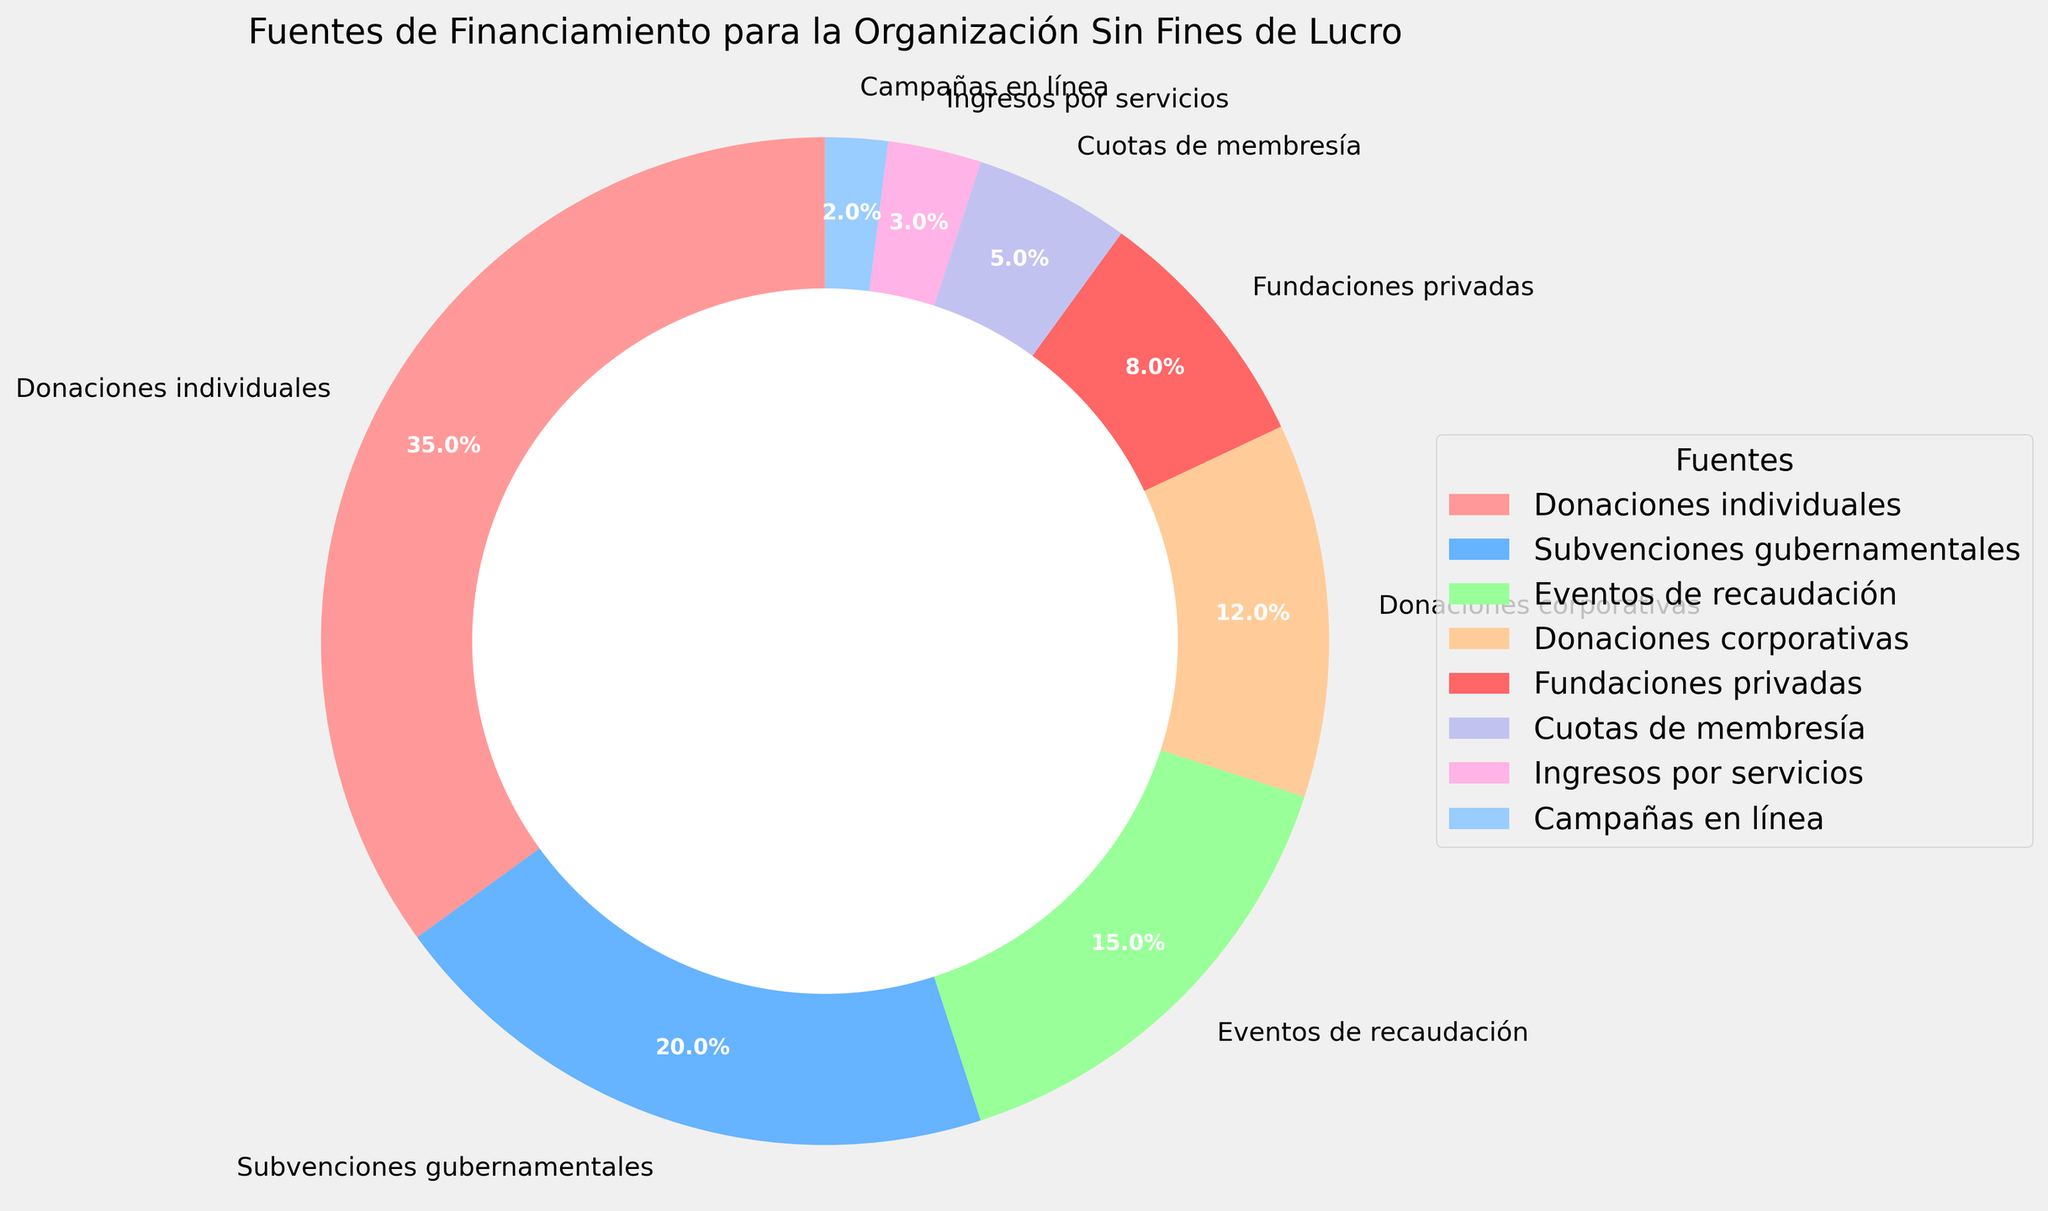Which source of funding has the highest percentage? The pie chart shows that "Donaciones individuales" (Individual Donations) has the largest section which represents 35% of the total funding. Thus, it has the highest percentage compared to other sources.
Answer: Donaciones individuales What is the combined percentage of "Subvenciones gubernamentales" and "Fundaciones privadas"? The percentages for "Subvenciones gubernamentales" (Government Grants) and "Fundaciones privadas" (Private Foundations) provided in the pie chart are 20% and 8%, respectively. Adding them together gives 20% + 8% = 28%.
Answer: 28% How much greater is the percentage of "Donaciones individuales" compared to "Eventos de recaudación"? The chart shows that "Donaciones individuales" (Individual Donations) is 35%, and "Eventos de recaudación" (Fundraising Events) is 15%. The difference is 35% - 15% = 20%.
Answer: 20% Which section of the pie chart is the smallest and how much is its percentage? The smallest section of the pie chart belongs to "Campañas en línea" (Online Campaigns), which has a percentage of 2%. This is identified by its small visual representation in the doughnut chart.
Answer: Campañas en línea Compare the sum of "Cuotas de membresía" and "Ingresos por servicios" with "Eventos de recaudación". Which one is larger and by how much? "Cuotas de membresía" (Membership Fees) and "Ingresos por servicios" (Service Revenue) add up to 5% + 3% = 8%. "Eventos de recaudación" (Fundraising Events) is 15%. The difference is 15% - 8% = 7%, which means "Eventos de recaudación" is larger by 7%.
Answer: Eventos de recaudación is larger by 7% What percentage of total funding comes from "Donaciones corporativas" and "Donaciones individuales" combined? According to the chart, "Donaciones corporativas" (Corporate Donations) is 12% and "Donaciones individuales" (Individual Donations) is 35%. The combined percentage is 12% + 35% = 47%.
Answer: 47% How does the visual representation of "Fundaciones privadas" compare in size to "Donaciones corporativas"? The section for "Fundaciones privadas" (Private Foundations) represents 8%, while "Donaciones corporativas" (Corporate Donations) represents 12%. Visually, "Donaciones corporativas" has a larger section compared to "Fundaciones privadas" in the pie chart.
Answer: Donaciones corporativas is larger 